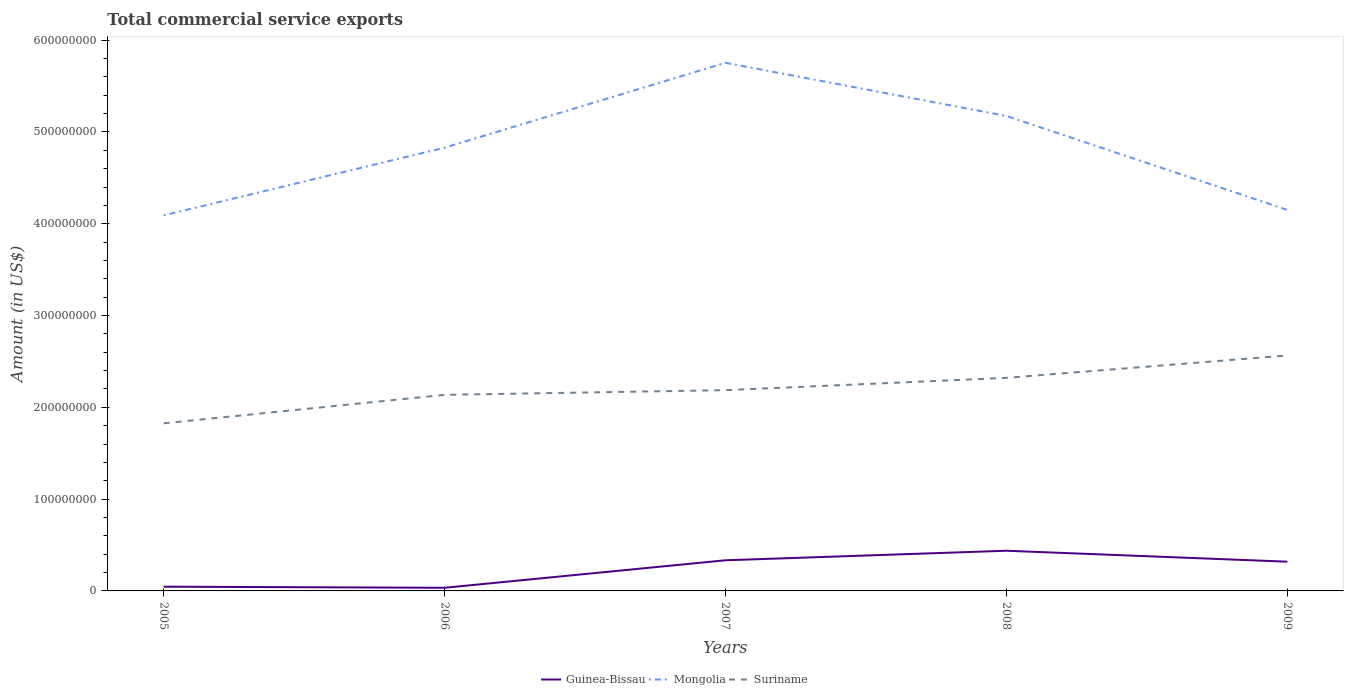Across all years, what is the maximum total commercial service exports in Guinea-Bissau?
Provide a succinct answer. 3.43e+06. In which year was the total commercial service exports in Mongolia maximum?
Your response must be concise. 2005. What is the total total commercial service exports in Suriname in the graph?
Make the answer very short. -1.34e+07. What is the difference between the highest and the second highest total commercial service exports in Mongolia?
Your answer should be compact. 1.66e+08. What is the difference between the highest and the lowest total commercial service exports in Mongolia?
Your answer should be very brief. 3. Is the total commercial service exports in Suriname strictly greater than the total commercial service exports in Guinea-Bissau over the years?
Provide a succinct answer. No. How many lines are there?
Keep it short and to the point. 3. How many years are there in the graph?
Ensure brevity in your answer.  5. Are the values on the major ticks of Y-axis written in scientific E-notation?
Keep it short and to the point. No. How are the legend labels stacked?
Your answer should be very brief. Horizontal. What is the title of the graph?
Your response must be concise. Total commercial service exports. Does "Dominican Republic" appear as one of the legend labels in the graph?
Ensure brevity in your answer.  No. What is the Amount (in US$) of Guinea-Bissau in 2005?
Offer a very short reply. 4.63e+06. What is the Amount (in US$) in Mongolia in 2005?
Provide a succinct answer. 4.09e+08. What is the Amount (in US$) in Suriname in 2005?
Give a very brief answer. 1.83e+08. What is the Amount (in US$) of Guinea-Bissau in 2006?
Give a very brief answer. 3.43e+06. What is the Amount (in US$) in Mongolia in 2006?
Give a very brief answer. 4.83e+08. What is the Amount (in US$) of Suriname in 2006?
Make the answer very short. 2.14e+08. What is the Amount (in US$) of Guinea-Bissau in 2007?
Offer a terse response. 3.34e+07. What is the Amount (in US$) in Mongolia in 2007?
Ensure brevity in your answer.  5.75e+08. What is the Amount (in US$) of Suriname in 2007?
Make the answer very short. 2.19e+08. What is the Amount (in US$) in Guinea-Bissau in 2008?
Make the answer very short. 4.38e+07. What is the Amount (in US$) of Mongolia in 2008?
Keep it short and to the point. 5.17e+08. What is the Amount (in US$) of Suriname in 2008?
Keep it short and to the point. 2.32e+08. What is the Amount (in US$) of Guinea-Bissau in 2009?
Provide a succinct answer. 3.19e+07. What is the Amount (in US$) of Mongolia in 2009?
Offer a very short reply. 4.15e+08. What is the Amount (in US$) of Suriname in 2009?
Give a very brief answer. 2.56e+08. Across all years, what is the maximum Amount (in US$) in Guinea-Bissau?
Your answer should be very brief. 4.38e+07. Across all years, what is the maximum Amount (in US$) of Mongolia?
Provide a short and direct response. 5.75e+08. Across all years, what is the maximum Amount (in US$) in Suriname?
Make the answer very short. 2.56e+08. Across all years, what is the minimum Amount (in US$) in Guinea-Bissau?
Your response must be concise. 3.43e+06. Across all years, what is the minimum Amount (in US$) of Mongolia?
Make the answer very short. 4.09e+08. Across all years, what is the minimum Amount (in US$) of Suriname?
Keep it short and to the point. 1.83e+08. What is the total Amount (in US$) of Guinea-Bissau in the graph?
Your answer should be compact. 1.17e+08. What is the total Amount (in US$) of Mongolia in the graph?
Your response must be concise. 2.40e+09. What is the total Amount (in US$) in Suriname in the graph?
Provide a short and direct response. 1.10e+09. What is the difference between the Amount (in US$) in Guinea-Bissau in 2005 and that in 2006?
Offer a very short reply. 1.21e+06. What is the difference between the Amount (in US$) in Mongolia in 2005 and that in 2006?
Offer a very short reply. -7.38e+07. What is the difference between the Amount (in US$) of Suriname in 2005 and that in 2006?
Keep it short and to the point. -3.10e+07. What is the difference between the Amount (in US$) of Guinea-Bissau in 2005 and that in 2007?
Provide a succinct answer. -2.88e+07. What is the difference between the Amount (in US$) in Mongolia in 2005 and that in 2007?
Provide a succinct answer. -1.66e+08. What is the difference between the Amount (in US$) in Suriname in 2005 and that in 2007?
Offer a terse response. -3.61e+07. What is the difference between the Amount (in US$) of Guinea-Bissau in 2005 and that in 2008?
Give a very brief answer. -3.91e+07. What is the difference between the Amount (in US$) in Mongolia in 2005 and that in 2008?
Your response must be concise. -1.08e+08. What is the difference between the Amount (in US$) in Suriname in 2005 and that in 2008?
Keep it short and to the point. -4.95e+07. What is the difference between the Amount (in US$) in Guinea-Bissau in 2005 and that in 2009?
Offer a very short reply. -2.72e+07. What is the difference between the Amount (in US$) in Mongolia in 2005 and that in 2009?
Make the answer very short. -5.97e+06. What is the difference between the Amount (in US$) in Suriname in 2005 and that in 2009?
Your answer should be very brief. -7.39e+07. What is the difference between the Amount (in US$) in Guinea-Bissau in 2006 and that in 2007?
Keep it short and to the point. -3.00e+07. What is the difference between the Amount (in US$) in Mongolia in 2006 and that in 2007?
Your answer should be compact. -9.24e+07. What is the difference between the Amount (in US$) in Suriname in 2006 and that in 2007?
Provide a succinct answer. -5.10e+06. What is the difference between the Amount (in US$) in Guinea-Bissau in 2006 and that in 2008?
Provide a succinct answer. -4.03e+07. What is the difference between the Amount (in US$) in Mongolia in 2006 and that in 2008?
Your response must be concise. -3.46e+07. What is the difference between the Amount (in US$) of Suriname in 2006 and that in 2008?
Ensure brevity in your answer.  -1.85e+07. What is the difference between the Amount (in US$) of Guinea-Bissau in 2006 and that in 2009?
Give a very brief answer. -2.84e+07. What is the difference between the Amount (in US$) in Mongolia in 2006 and that in 2009?
Your answer should be very brief. 6.78e+07. What is the difference between the Amount (in US$) in Suriname in 2006 and that in 2009?
Ensure brevity in your answer.  -4.29e+07. What is the difference between the Amount (in US$) of Guinea-Bissau in 2007 and that in 2008?
Keep it short and to the point. -1.04e+07. What is the difference between the Amount (in US$) in Mongolia in 2007 and that in 2008?
Give a very brief answer. 5.79e+07. What is the difference between the Amount (in US$) in Suriname in 2007 and that in 2008?
Your response must be concise. -1.34e+07. What is the difference between the Amount (in US$) in Guinea-Bissau in 2007 and that in 2009?
Ensure brevity in your answer.  1.54e+06. What is the difference between the Amount (in US$) in Mongolia in 2007 and that in 2009?
Keep it short and to the point. 1.60e+08. What is the difference between the Amount (in US$) in Suriname in 2007 and that in 2009?
Offer a very short reply. -3.78e+07. What is the difference between the Amount (in US$) of Guinea-Bissau in 2008 and that in 2009?
Provide a short and direct response. 1.19e+07. What is the difference between the Amount (in US$) of Mongolia in 2008 and that in 2009?
Offer a very short reply. 1.02e+08. What is the difference between the Amount (in US$) in Suriname in 2008 and that in 2009?
Keep it short and to the point. -2.44e+07. What is the difference between the Amount (in US$) of Guinea-Bissau in 2005 and the Amount (in US$) of Mongolia in 2006?
Keep it short and to the point. -4.78e+08. What is the difference between the Amount (in US$) of Guinea-Bissau in 2005 and the Amount (in US$) of Suriname in 2006?
Keep it short and to the point. -2.09e+08. What is the difference between the Amount (in US$) of Mongolia in 2005 and the Amount (in US$) of Suriname in 2006?
Keep it short and to the point. 1.96e+08. What is the difference between the Amount (in US$) in Guinea-Bissau in 2005 and the Amount (in US$) in Mongolia in 2007?
Ensure brevity in your answer.  -5.71e+08. What is the difference between the Amount (in US$) in Guinea-Bissau in 2005 and the Amount (in US$) in Suriname in 2007?
Make the answer very short. -2.14e+08. What is the difference between the Amount (in US$) in Mongolia in 2005 and the Amount (in US$) in Suriname in 2007?
Offer a very short reply. 1.90e+08. What is the difference between the Amount (in US$) of Guinea-Bissau in 2005 and the Amount (in US$) of Mongolia in 2008?
Provide a succinct answer. -5.13e+08. What is the difference between the Amount (in US$) in Guinea-Bissau in 2005 and the Amount (in US$) in Suriname in 2008?
Your response must be concise. -2.27e+08. What is the difference between the Amount (in US$) of Mongolia in 2005 and the Amount (in US$) of Suriname in 2008?
Your response must be concise. 1.77e+08. What is the difference between the Amount (in US$) of Guinea-Bissau in 2005 and the Amount (in US$) of Mongolia in 2009?
Your answer should be compact. -4.10e+08. What is the difference between the Amount (in US$) of Guinea-Bissau in 2005 and the Amount (in US$) of Suriname in 2009?
Your answer should be compact. -2.52e+08. What is the difference between the Amount (in US$) of Mongolia in 2005 and the Amount (in US$) of Suriname in 2009?
Give a very brief answer. 1.53e+08. What is the difference between the Amount (in US$) of Guinea-Bissau in 2006 and the Amount (in US$) of Mongolia in 2007?
Offer a very short reply. -5.72e+08. What is the difference between the Amount (in US$) of Guinea-Bissau in 2006 and the Amount (in US$) of Suriname in 2007?
Your answer should be compact. -2.15e+08. What is the difference between the Amount (in US$) in Mongolia in 2006 and the Amount (in US$) in Suriname in 2007?
Your response must be concise. 2.64e+08. What is the difference between the Amount (in US$) of Guinea-Bissau in 2006 and the Amount (in US$) of Mongolia in 2008?
Keep it short and to the point. -5.14e+08. What is the difference between the Amount (in US$) in Guinea-Bissau in 2006 and the Amount (in US$) in Suriname in 2008?
Offer a terse response. -2.29e+08. What is the difference between the Amount (in US$) in Mongolia in 2006 and the Amount (in US$) in Suriname in 2008?
Make the answer very short. 2.51e+08. What is the difference between the Amount (in US$) in Guinea-Bissau in 2006 and the Amount (in US$) in Mongolia in 2009?
Provide a succinct answer. -4.12e+08. What is the difference between the Amount (in US$) in Guinea-Bissau in 2006 and the Amount (in US$) in Suriname in 2009?
Offer a terse response. -2.53e+08. What is the difference between the Amount (in US$) in Mongolia in 2006 and the Amount (in US$) in Suriname in 2009?
Keep it short and to the point. 2.26e+08. What is the difference between the Amount (in US$) of Guinea-Bissau in 2007 and the Amount (in US$) of Mongolia in 2008?
Your answer should be very brief. -4.84e+08. What is the difference between the Amount (in US$) in Guinea-Bissau in 2007 and the Amount (in US$) in Suriname in 2008?
Provide a short and direct response. -1.99e+08. What is the difference between the Amount (in US$) of Mongolia in 2007 and the Amount (in US$) of Suriname in 2008?
Your answer should be very brief. 3.43e+08. What is the difference between the Amount (in US$) in Guinea-Bissau in 2007 and the Amount (in US$) in Mongolia in 2009?
Give a very brief answer. -3.82e+08. What is the difference between the Amount (in US$) in Guinea-Bissau in 2007 and the Amount (in US$) in Suriname in 2009?
Ensure brevity in your answer.  -2.23e+08. What is the difference between the Amount (in US$) in Mongolia in 2007 and the Amount (in US$) in Suriname in 2009?
Your answer should be compact. 3.19e+08. What is the difference between the Amount (in US$) in Guinea-Bissau in 2008 and the Amount (in US$) in Mongolia in 2009?
Give a very brief answer. -3.71e+08. What is the difference between the Amount (in US$) of Guinea-Bissau in 2008 and the Amount (in US$) of Suriname in 2009?
Your answer should be compact. -2.13e+08. What is the difference between the Amount (in US$) in Mongolia in 2008 and the Amount (in US$) in Suriname in 2009?
Offer a very short reply. 2.61e+08. What is the average Amount (in US$) in Guinea-Bissau per year?
Ensure brevity in your answer.  2.34e+07. What is the average Amount (in US$) of Mongolia per year?
Provide a short and direct response. 4.80e+08. What is the average Amount (in US$) of Suriname per year?
Offer a terse response. 2.21e+08. In the year 2005, what is the difference between the Amount (in US$) in Guinea-Bissau and Amount (in US$) in Mongolia?
Keep it short and to the point. -4.04e+08. In the year 2005, what is the difference between the Amount (in US$) in Guinea-Bissau and Amount (in US$) in Suriname?
Your answer should be very brief. -1.78e+08. In the year 2005, what is the difference between the Amount (in US$) in Mongolia and Amount (in US$) in Suriname?
Provide a succinct answer. 2.27e+08. In the year 2006, what is the difference between the Amount (in US$) of Guinea-Bissau and Amount (in US$) of Mongolia?
Provide a succinct answer. -4.79e+08. In the year 2006, what is the difference between the Amount (in US$) in Guinea-Bissau and Amount (in US$) in Suriname?
Make the answer very short. -2.10e+08. In the year 2006, what is the difference between the Amount (in US$) of Mongolia and Amount (in US$) of Suriname?
Keep it short and to the point. 2.69e+08. In the year 2007, what is the difference between the Amount (in US$) of Guinea-Bissau and Amount (in US$) of Mongolia?
Offer a terse response. -5.42e+08. In the year 2007, what is the difference between the Amount (in US$) in Guinea-Bissau and Amount (in US$) in Suriname?
Offer a very short reply. -1.85e+08. In the year 2007, what is the difference between the Amount (in US$) of Mongolia and Amount (in US$) of Suriname?
Make the answer very short. 3.57e+08. In the year 2008, what is the difference between the Amount (in US$) in Guinea-Bissau and Amount (in US$) in Mongolia?
Provide a succinct answer. -4.74e+08. In the year 2008, what is the difference between the Amount (in US$) in Guinea-Bissau and Amount (in US$) in Suriname?
Your answer should be compact. -1.88e+08. In the year 2008, what is the difference between the Amount (in US$) of Mongolia and Amount (in US$) of Suriname?
Your response must be concise. 2.85e+08. In the year 2009, what is the difference between the Amount (in US$) in Guinea-Bissau and Amount (in US$) in Mongolia?
Ensure brevity in your answer.  -3.83e+08. In the year 2009, what is the difference between the Amount (in US$) of Guinea-Bissau and Amount (in US$) of Suriname?
Provide a short and direct response. -2.25e+08. In the year 2009, what is the difference between the Amount (in US$) in Mongolia and Amount (in US$) in Suriname?
Give a very brief answer. 1.59e+08. What is the ratio of the Amount (in US$) in Guinea-Bissau in 2005 to that in 2006?
Keep it short and to the point. 1.35. What is the ratio of the Amount (in US$) of Mongolia in 2005 to that in 2006?
Your answer should be compact. 0.85. What is the ratio of the Amount (in US$) of Suriname in 2005 to that in 2006?
Give a very brief answer. 0.85. What is the ratio of the Amount (in US$) in Guinea-Bissau in 2005 to that in 2007?
Keep it short and to the point. 0.14. What is the ratio of the Amount (in US$) in Mongolia in 2005 to that in 2007?
Provide a succinct answer. 0.71. What is the ratio of the Amount (in US$) of Suriname in 2005 to that in 2007?
Give a very brief answer. 0.83. What is the ratio of the Amount (in US$) in Guinea-Bissau in 2005 to that in 2008?
Your response must be concise. 0.11. What is the ratio of the Amount (in US$) in Mongolia in 2005 to that in 2008?
Keep it short and to the point. 0.79. What is the ratio of the Amount (in US$) of Suriname in 2005 to that in 2008?
Keep it short and to the point. 0.79. What is the ratio of the Amount (in US$) in Guinea-Bissau in 2005 to that in 2009?
Offer a terse response. 0.15. What is the ratio of the Amount (in US$) of Mongolia in 2005 to that in 2009?
Keep it short and to the point. 0.99. What is the ratio of the Amount (in US$) of Suriname in 2005 to that in 2009?
Your answer should be compact. 0.71. What is the ratio of the Amount (in US$) in Guinea-Bissau in 2006 to that in 2007?
Provide a short and direct response. 0.1. What is the ratio of the Amount (in US$) of Mongolia in 2006 to that in 2007?
Ensure brevity in your answer.  0.84. What is the ratio of the Amount (in US$) of Suriname in 2006 to that in 2007?
Keep it short and to the point. 0.98. What is the ratio of the Amount (in US$) in Guinea-Bissau in 2006 to that in 2008?
Offer a very short reply. 0.08. What is the ratio of the Amount (in US$) in Mongolia in 2006 to that in 2008?
Offer a very short reply. 0.93. What is the ratio of the Amount (in US$) of Suriname in 2006 to that in 2008?
Provide a succinct answer. 0.92. What is the ratio of the Amount (in US$) of Guinea-Bissau in 2006 to that in 2009?
Your answer should be compact. 0.11. What is the ratio of the Amount (in US$) of Mongolia in 2006 to that in 2009?
Provide a succinct answer. 1.16. What is the ratio of the Amount (in US$) in Suriname in 2006 to that in 2009?
Make the answer very short. 0.83. What is the ratio of the Amount (in US$) of Guinea-Bissau in 2007 to that in 2008?
Provide a succinct answer. 0.76. What is the ratio of the Amount (in US$) in Mongolia in 2007 to that in 2008?
Offer a very short reply. 1.11. What is the ratio of the Amount (in US$) of Suriname in 2007 to that in 2008?
Provide a succinct answer. 0.94. What is the ratio of the Amount (in US$) of Guinea-Bissau in 2007 to that in 2009?
Keep it short and to the point. 1.05. What is the ratio of the Amount (in US$) in Mongolia in 2007 to that in 2009?
Provide a succinct answer. 1.39. What is the ratio of the Amount (in US$) of Suriname in 2007 to that in 2009?
Provide a short and direct response. 0.85. What is the ratio of the Amount (in US$) of Guinea-Bissau in 2008 to that in 2009?
Make the answer very short. 1.37. What is the ratio of the Amount (in US$) of Mongolia in 2008 to that in 2009?
Provide a succinct answer. 1.25. What is the ratio of the Amount (in US$) in Suriname in 2008 to that in 2009?
Keep it short and to the point. 0.9. What is the difference between the highest and the second highest Amount (in US$) in Guinea-Bissau?
Give a very brief answer. 1.04e+07. What is the difference between the highest and the second highest Amount (in US$) of Mongolia?
Make the answer very short. 5.79e+07. What is the difference between the highest and the second highest Amount (in US$) of Suriname?
Your answer should be very brief. 2.44e+07. What is the difference between the highest and the lowest Amount (in US$) in Guinea-Bissau?
Ensure brevity in your answer.  4.03e+07. What is the difference between the highest and the lowest Amount (in US$) of Mongolia?
Make the answer very short. 1.66e+08. What is the difference between the highest and the lowest Amount (in US$) in Suriname?
Offer a very short reply. 7.39e+07. 